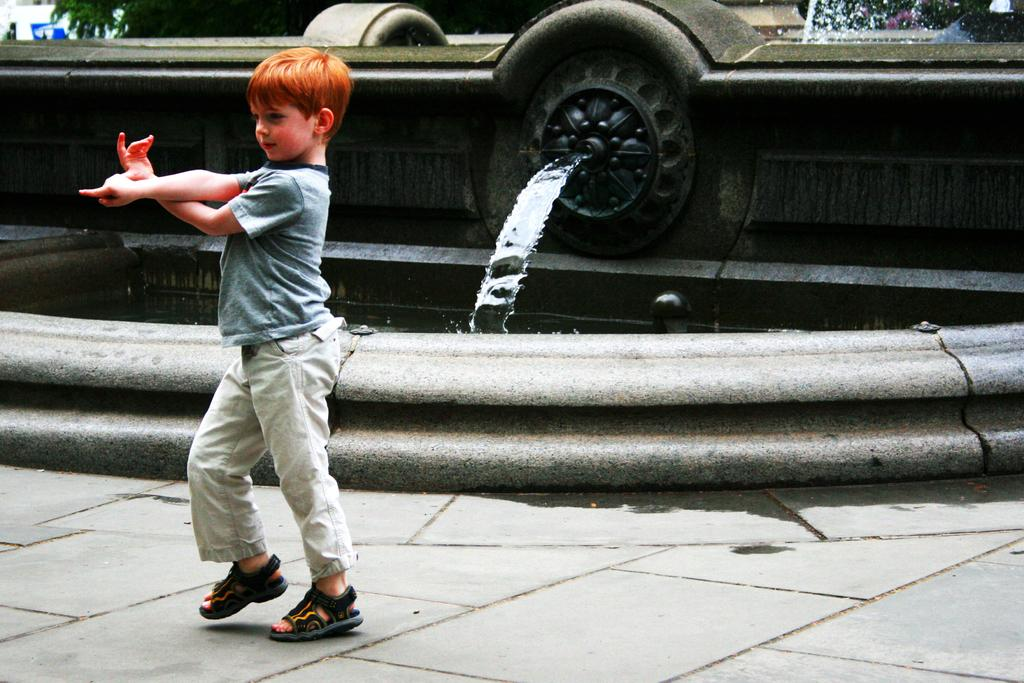Where was the picture taken? The picture was clicked outside. Who is the main subject in the image? There is a kid in the image. What is the kid wearing? The kid is wearing a t-shirt. What is the kid doing in the image? The kid appears to be dancing on the ground. What can be seen in the background of the image? There is a waterfall and other objects visible in the background of the image. How much waste is visible in the image? There is no mention of waste in the image, so it cannot be determined from the picture. 